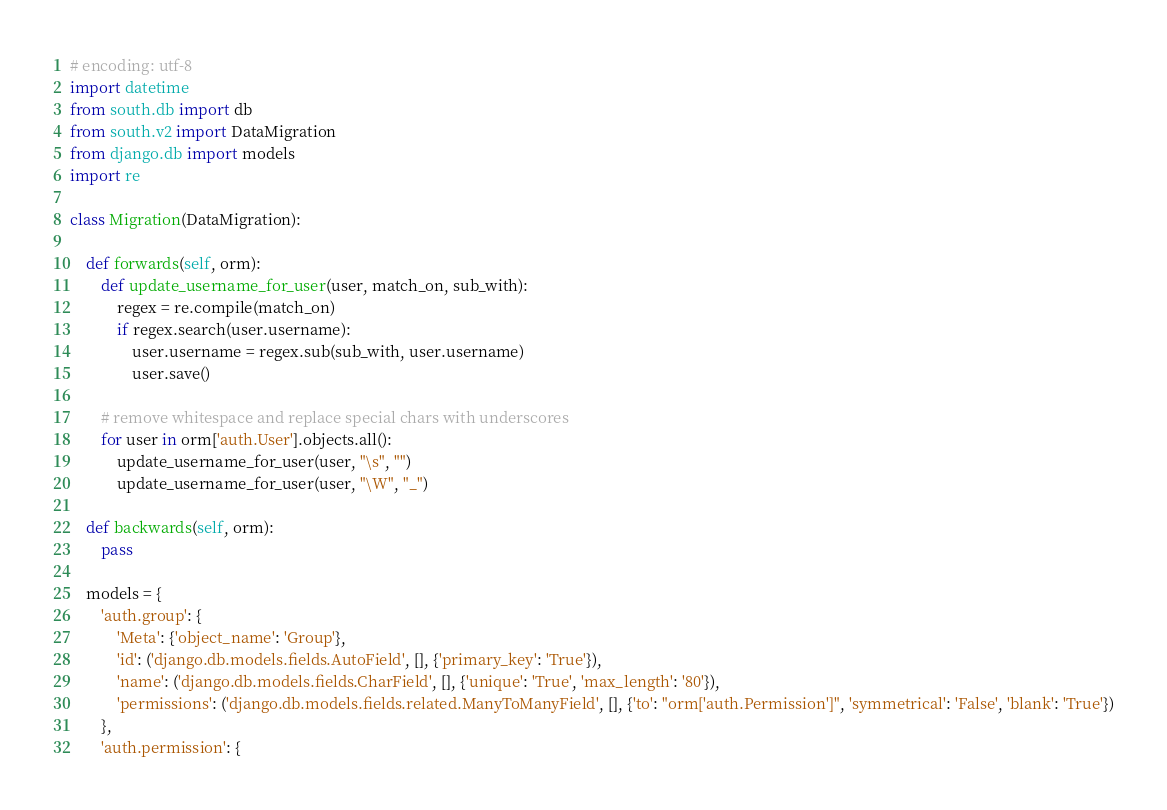Convert code to text. <code><loc_0><loc_0><loc_500><loc_500><_Python_># encoding: utf-8
import datetime
from south.db import db
from south.v2 import DataMigration
from django.db import models
import re

class Migration(DataMigration):

    def forwards(self, orm):
        def update_username_for_user(user, match_on, sub_with):
            regex = re.compile(match_on)
            if regex.search(user.username):
                user.username = regex.sub(sub_with, user.username)
                user.save()

        # remove whitespace and replace special chars with underscores
        for user in orm['auth.User'].objects.all():
            update_username_for_user(user, "\s", "")
            update_username_for_user(user, "\W", "_")

    def backwards(self, orm):
        pass

    models = {
        'auth.group': {
            'Meta': {'object_name': 'Group'},
            'id': ('django.db.models.fields.AutoField', [], {'primary_key': 'True'}),
            'name': ('django.db.models.fields.CharField', [], {'unique': 'True', 'max_length': '80'}),
            'permissions': ('django.db.models.fields.related.ManyToManyField', [], {'to': "orm['auth.Permission']", 'symmetrical': 'False', 'blank': 'True'})
        },
        'auth.permission': {</code> 